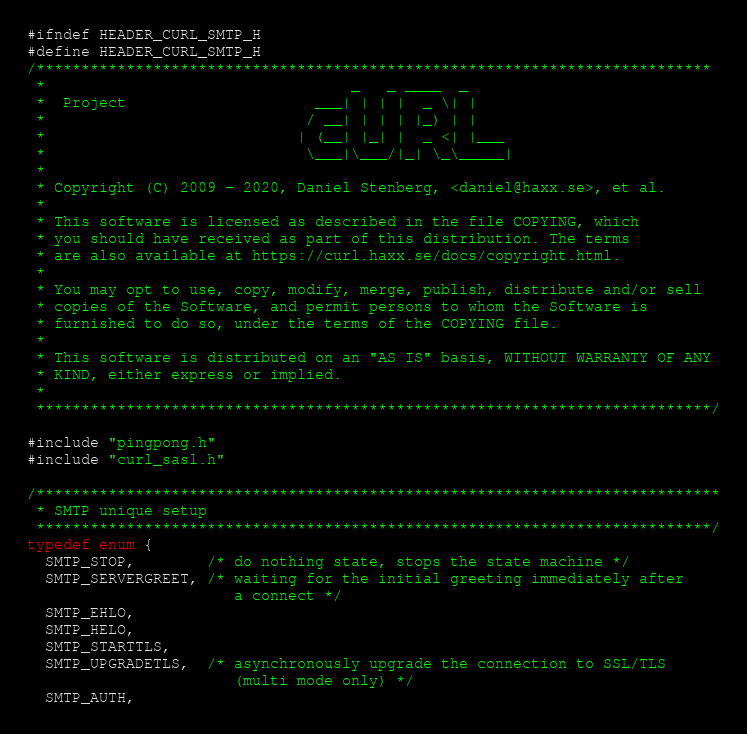Convert code to text. <code><loc_0><loc_0><loc_500><loc_500><_C_>#ifndef HEADER_CURL_SMTP_H
#define HEADER_CURL_SMTP_H
/***************************************************************************
 *                                  _   _ ____  _
 *  Project                     ___| | | |  _ \| |
 *                             / __| | | | |_) | |
 *                            | (__| |_| |  _ <| |___
 *                             \___|\___/|_| \_\_____|
 *
 * Copyright (C) 2009 - 2020, Daniel Stenberg, <daniel@haxx.se>, et al.
 *
 * This software is licensed as described in the file COPYING, which
 * you should have received as part of this distribution. The terms
 * are also available at https://curl.haxx.se/docs/copyright.html.
 *
 * You may opt to use, copy, modify, merge, publish, distribute and/or sell
 * copies of the Software, and permit persons to whom the Software is
 * furnished to do so, under the terms of the COPYING file.
 *
 * This software is distributed on an "AS IS" basis, WITHOUT WARRANTY OF ANY
 * KIND, either express or implied.
 *
 ***************************************************************************/

#include "pingpong.h"
#include "curl_sasl.h"

/****************************************************************************
 * SMTP unique setup
 ***************************************************************************/
typedef enum {
  SMTP_STOP,        /* do nothing state, stops the state machine */
  SMTP_SERVERGREET, /* waiting for the initial greeting immediately after
                       a connect */
  SMTP_EHLO,
  SMTP_HELO,
  SMTP_STARTTLS,
  SMTP_UPGRADETLS,  /* asynchronously upgrade the connection to SSL/TLS
                       (multi mode only) */
  SMTP_AUTH,</code> 